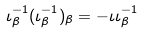Convert formula to latex. <formula><loc_0><loc_0><loc_500><loc_500>\iota ^ { - 1 } _ { \beta } ( \iota ^ { - 1 } _ { \beta } ) _ { \beta } = - \iota \iota ^ { - 1 } _ { \beta }</formula> 